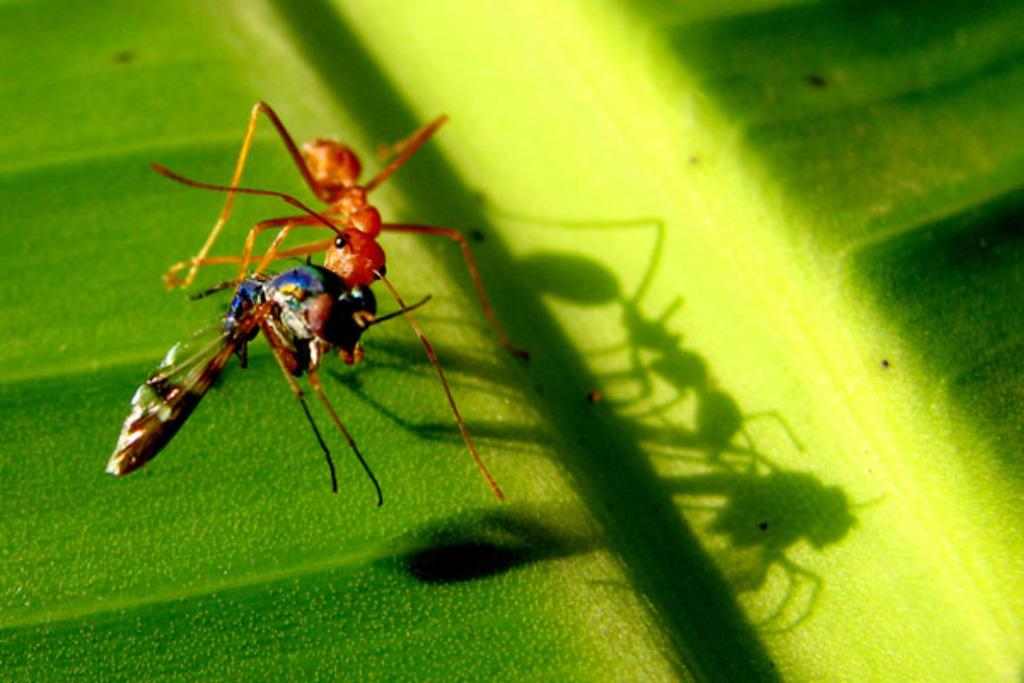How many insects are present in the image? There are two insects in the image. What is the color of the surface where the insects are located? The insects are on a green surface. Can you hear the insects laughing in the image? There is no sound in the image, so it is not possible to hear the insects laughing. 